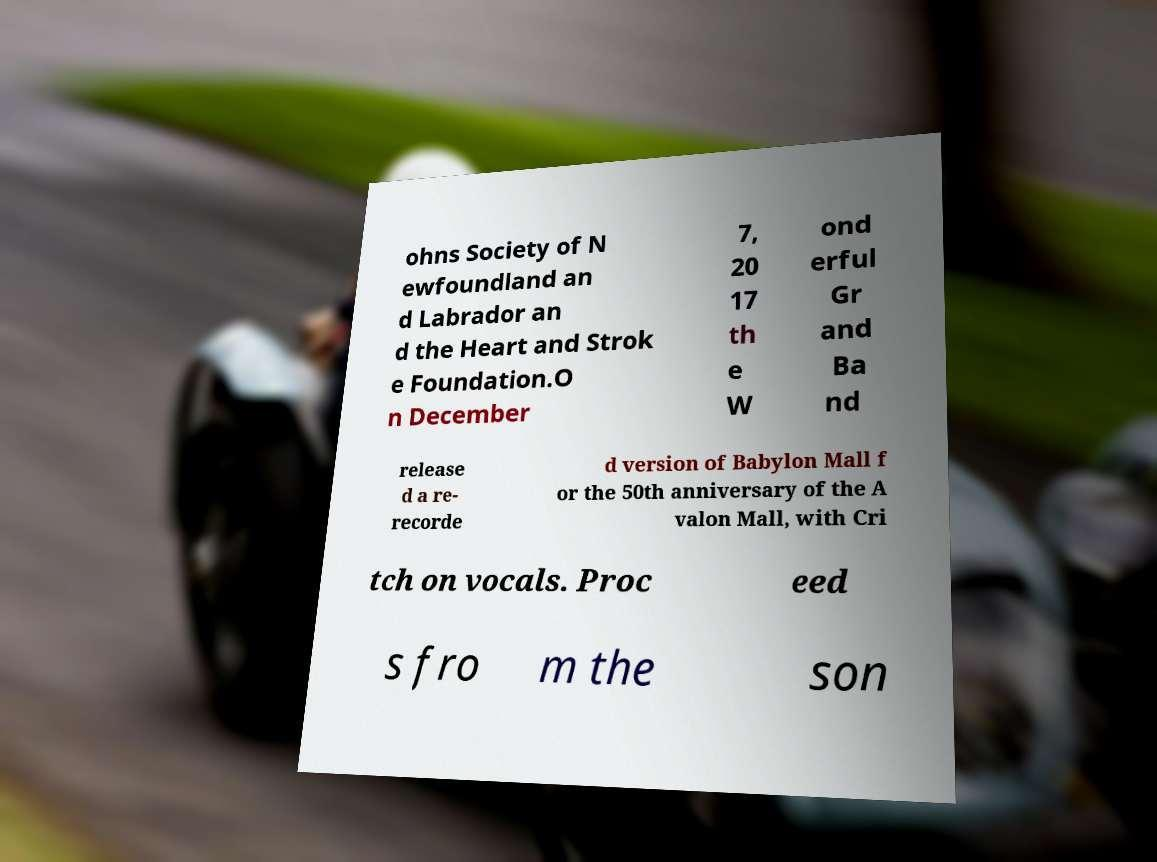For documentation purposes, I need the text within this image transcribed. Could you provide that? ohns Society of N ewfoundland an d Labrador an d the Heart and Strok e Foundation.O n December 7, 20 17 th e W ond erful Gr and Ba nd release d a re- recorde d version of Babylon Mall f or the 50th anniversary of the A valon Mall, with Cri tch on vocals. Proc eed s fro m the son 